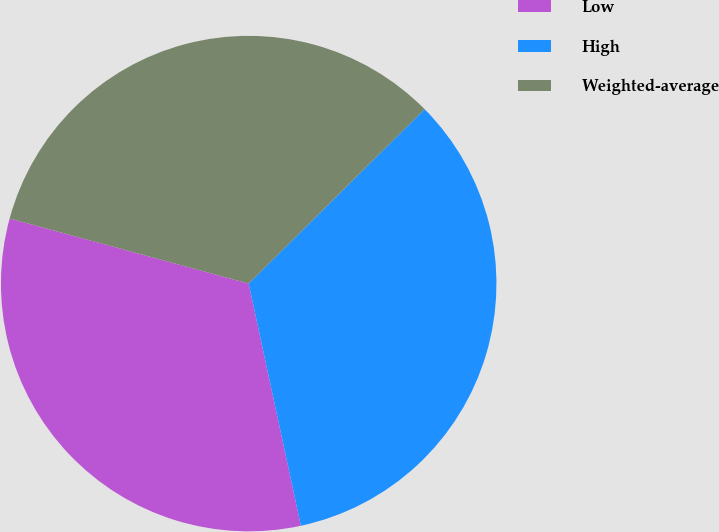Convert chart to OTSL. <chart><loc_0><loc_0><loc_500><loc_500><pie_chart><fcel>Low<fcel>High<fcel>Weighted-average<nl><fcel>32.61%<fcel>34.05%<fcel>33.33%<nl></chart> 